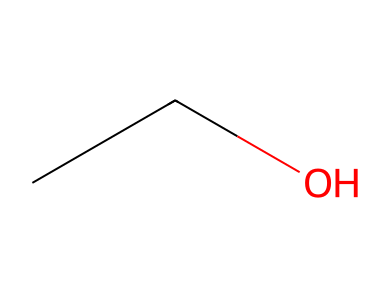What is the molecular formula of this chemical? From the SMILES representation "CCO," we can see that there are two carbon atoms (C) and six hydrogen atoms (H) and one oxygen atom (O). This gives us the molecular formula C2H6O.
Answer: C2H6O How many carbon atoms are in ethanol? The SMILES representation has two 'C' characters, which indicate that there are two carbon atoms.
Answer: 2 What type of compound is ethanol? Ethanol is classified as an alcohol, which can be deduced from the presence of the hydroxyl group (-OH) when examining the structure.
Answer: alcohol Is ethanol flammable? Ethanol is known to be a flammable liquid due to its low flash point, making it capable of igniting easily in air.
Answer: yes What functional group is present in ethanol? Ethanol contains a hydroxyl functional group (-OH), which characterizes it as an alcohol. This can be recognized through the integrated 'O' in the SMILES, indicating the presence of oxygen bonded to hydrogen.
Answer: hydroxyl How many total hydrogen atoms are in ethanol? By counting the hydrogen atoms in the SMILES "CCO", we find that there are six hydrogen atoms bonded to the two carbon atoms and the oxygen atom.
Answer: 6 What chemical property makes ethanol useful in preservation? The ability of ethanol to act as a preservative is largely due to its antibacterial properties and ability to denature proteins, which can be inferred from its structure and functional group.
Answer: antibacterial 